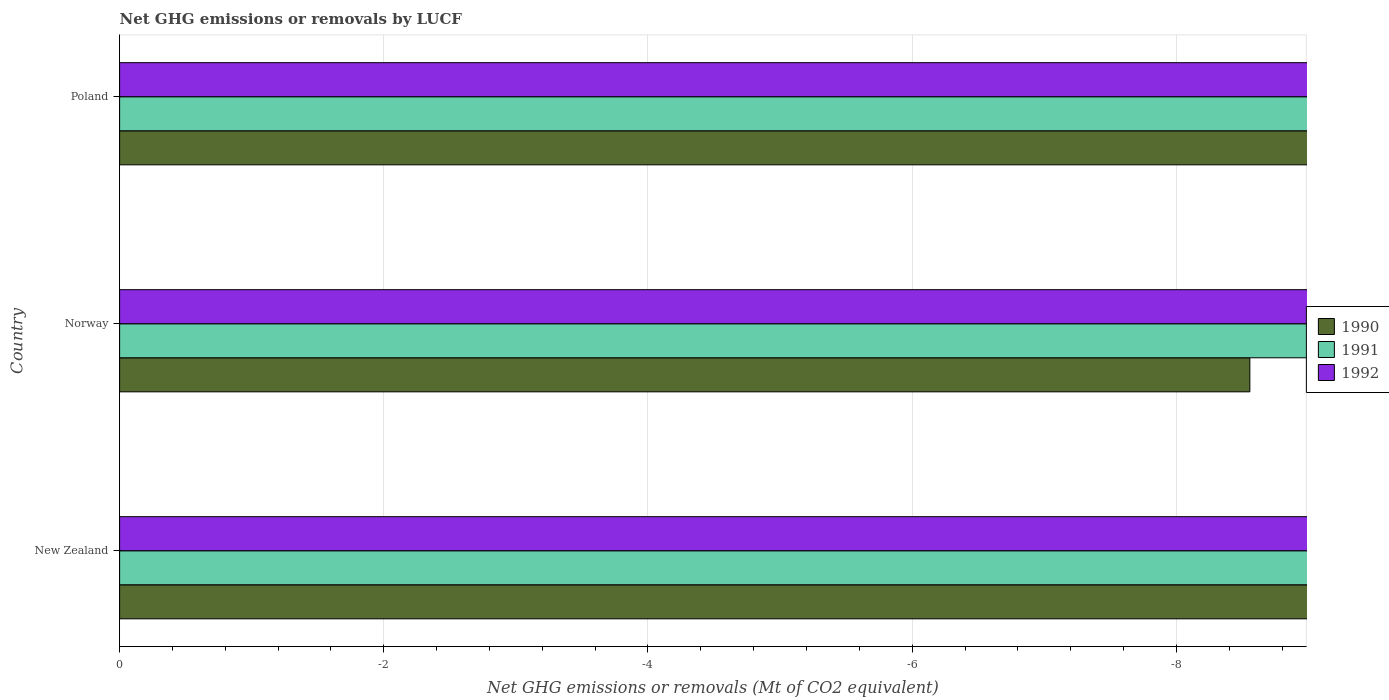How many different coloured bars are there?
Provide a succinct answer. 0. Are the number of bars per tick equal to the number of legend labels?
Your answer should be compact. No. How many bars are there on the 3rd tick from the top?
Provide a succinct answer. 0. What is the label of the 2nd group of bars from the top?
Your response must be concise. Norway. In how many cases, is the number of bars for a given country not equal to the number of legend labels?
Make the answer very short. 3. Across all countries, what is the minimum net GHG emissions or removals by LUCF in 1990?
Offer a terse response. 0. What is the total net GHG emissions or removals by LUCF in 1990 in the graph?
Your response must be concise. 0. What is the difference between the net GHG emissions or removals by LUCF in 1992 in New Zealand and the net GHG emissions or removals by LUCF in 1990 in Norway?
Ensure brevity in your answer.  0. What is the average net GHG emissions or removals by LUCF in 1990 per country?
Ensure brevity in your answer.  0. How many bars are there?
Offer a terse response. 0. How many countries are there in the graph?
Give a very brief answer. 3. What is the difference between two consecutive major ticks on the X-axis?
Offer a very short reply. 2. Are the values on the major ticks of X-axis written in scientific E-notation?
Provide a succinct answer. No. Where does the legend appear in the graph?
Make the answer very short. Center right. How are the legend labels stacked?
Offer a terse response. Vertical. What is the title of the graph?
Provide a succinct answer. Net GHG emissions or removals by LUCF. What is the label or title of the X-axis?
Keep it short and to the point. Net GHG emissions or removals (Mt of CO2 equivalent). What is the label or title of the Y-axis?
Your response must be concise. Country. What is the Net GHG emissions or removals (Mt of CO2 equivalent) in 1992 in New Zealand?
Offer a very short reply. 0. What is the Net GHG emissions or removals (Mt of CO2 equivalent) in 1990 in Norway?
Give a very brief answer. 0. What is the Net GHG emissions or removals (Mt of CO2 equivalent) of 1991 in Norway?
Ensure brevity in your answer.  0. What is the Net GHG emissions or removals (Mt of CO2 equivalent) in 1992 in Poland?
Make the answer very short. 0. What is the total Net GHG emissions or removals (Mt of CO2 equivalent) of 1990 in the graph?
Provide a succinct answer. 0. What is the average Net GHG emissions or removals (Mt of CO2 equivalent) of 1990 per country?
Your response must be concise. 0. 